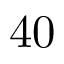Convert formula to latex. <formula><loc_0><loc_0><loc_500><loc_500>4 0</formula> 